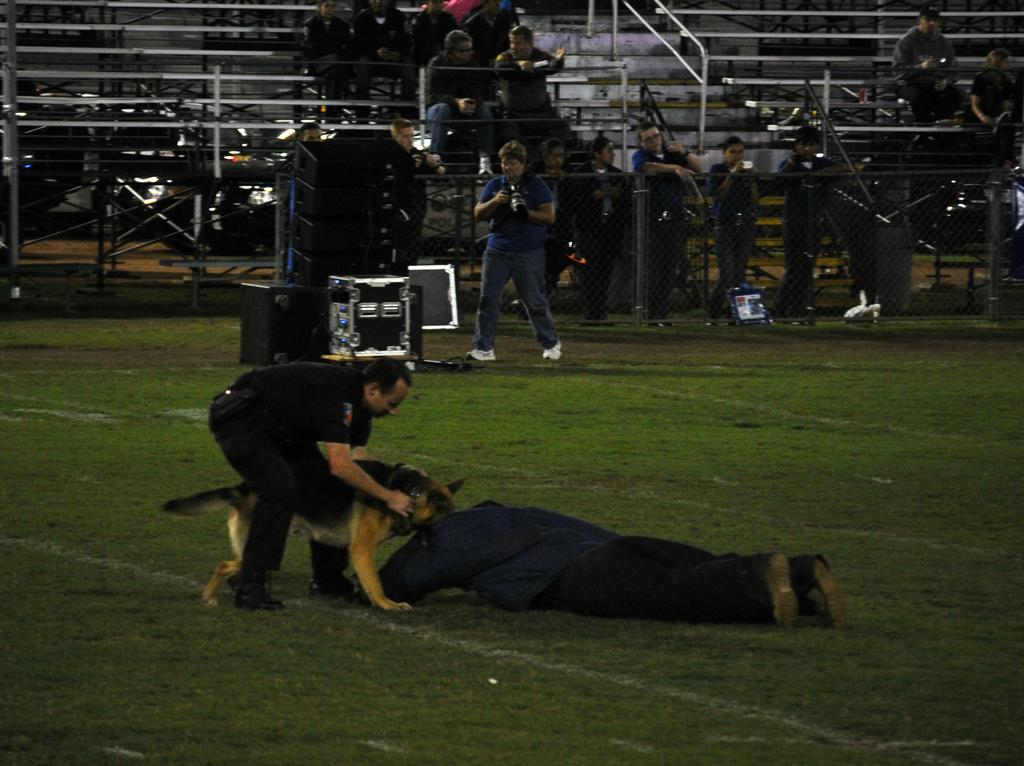How many people are in the image? There is a group of people in the image. What is the man in the image doing? The man is laying down on the ground. What animal is present in the image? A dog is present in the image. What is the dog doing in the image? The dog is sniffing the man. What can be seen on the ground in the image? There are objects visible on the ground. How many ladybugs are crawling on the hose in the image? There is no hose or ladybugs present in the image. 